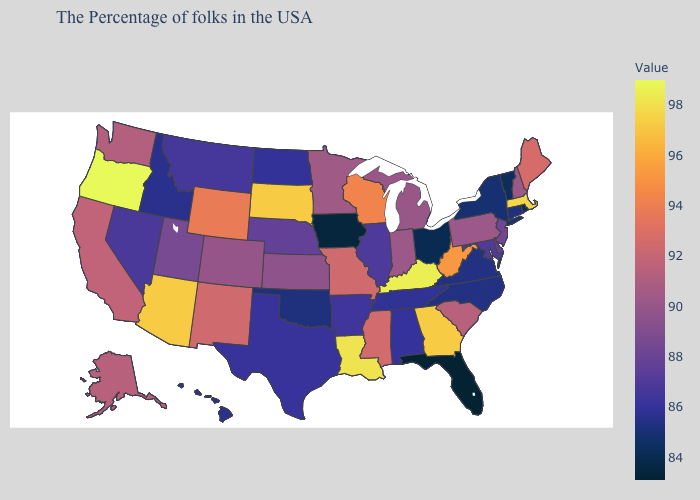Does Florida have the lowest value in the USA?
Short answer required. Yes. Which states have the lowest value in the West?
Keep it brief. Idaho, Hawaii. Does the map have missing data?
Concise answer only. No. Among the states that border South Dakota , which have the lowest value?
Write a very short answer. Iowa. Which states have the highest value in the USA?
Give a very brief answer. Oregon. Among the states that border South Dakota , which have the highest value?
Give a very brief answer. Wyoming. 